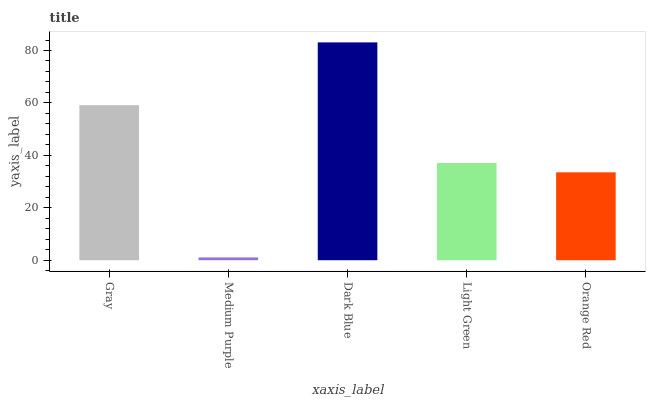Is Dark Blue the minimum?
Answer yes or no. No. Is Medium Purple the maximum?
Answer yes or no. No. Is Dark Blue greater than Medium Purple?
Answer yes or no. Yes. Is Medium Purple less than Dark Blue?
Answer yes or no. Yes. Is Medium Purple greater than Dark Blue?
Answer yes or no. No. Is Dark Blue less than Medium Purple?
Answer yes or no. No. Is Light Green the high median?
Answer yes or no. Yes. Is Light Green the low median?
Answer yes or no. Yes. Is Dark Blue the high median?
Answer yes or no. No. Is Dark Blue the low median?
Answer yes or no. No. 